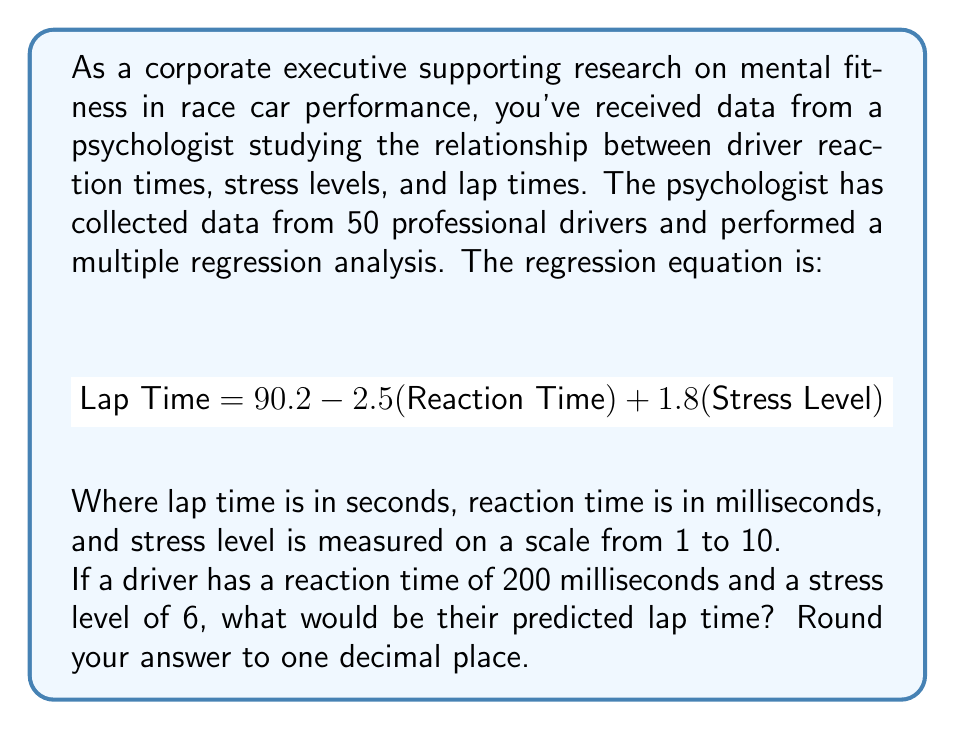Give your solution to this math problem. To solve this problem, we need to use the given multiple regression equation and substitute the values for reaction time and stress level. Let's break it down step by step:

1. The multiple regression equation is:
   $$\text{Lap Time} = 90.2 - 2.5(\text{Reaction Time}) + 1.8(\text{Stress Level})$$

2. We're given:
   - Reaction Time = 200 milliseconds
   - Stress Level = 6

3. Let's substitute these values into the equation:
   $$\text{Lap Time} = 90.2 - 2.5(200) + 1.8(6)$$

4. Now, let's calculate each term:
   - $90.2$ remains as is
   - $-2.5(200) = -500$
   - $1.8(6) = 10.8$

5. Adding these terms:
   $$\text{Lap Time} = 90.2 + (-500) + 10.8$$
   $$\text{Lap Time} = -399 + 10.8$$
   $$\text{Lap Time} = -388.2$$

6. The final step is to round to one decimal place:
   $$\text{Lap Time} ≈ -388.2$$
Answer: $-388.2$ seconds 